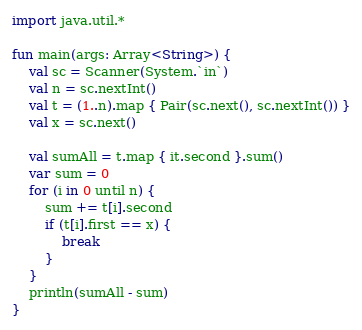<code> <loc_0><loc_0><loc_500><loc_500><_Kotlin_>import java.util.*

fun main(args: Array<String>) {
    val sc = Scanner(System.`in`)
    val n = sc.nextInt()
    val t = (1..n).map { Pair(sc.next(), sc.nextInt()) }
    val x = sc.next()

    val sumAll = t.map { it.second }.sum()
    var sum = 0
    for (i in 0 until n) {
        sum += t[i].second
        if (t[i].first == x) {
            break
        }
    }
    println(sumAll - sum)
}</code> 